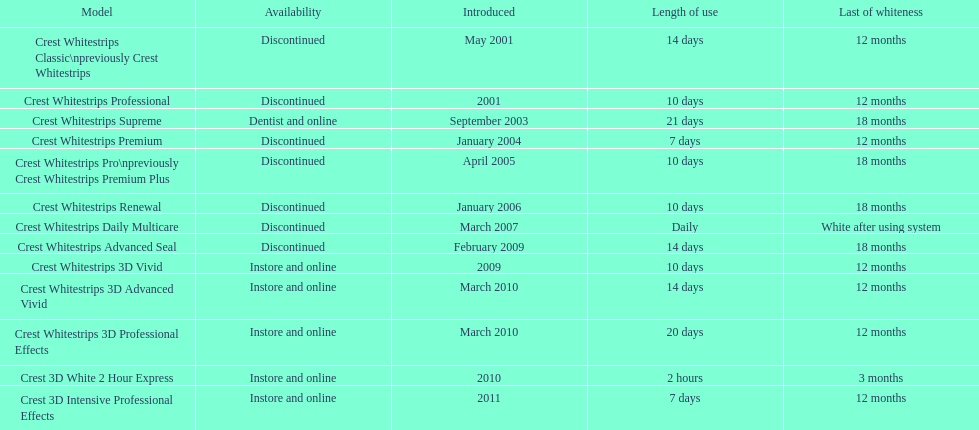Do the crest white strips classic have a lasting effect of at least one year? Yes. 